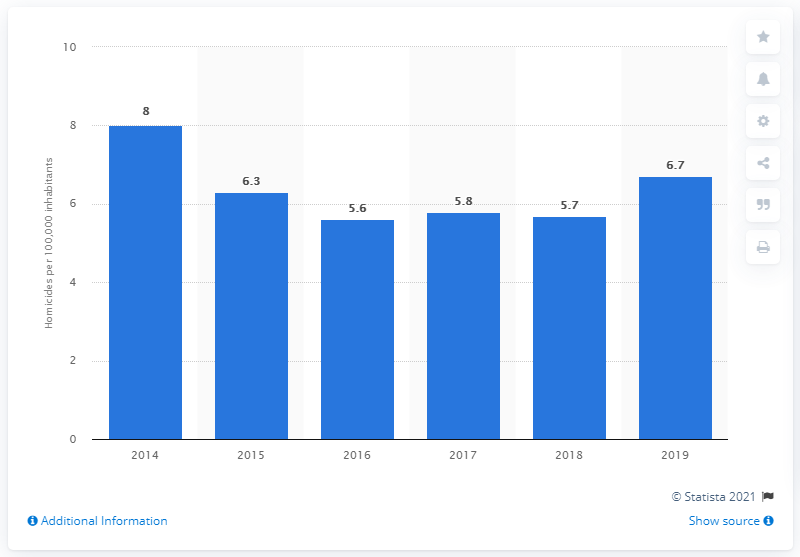Mention a couple of crucial points in this snapshot. In 2019, the homicide rate in Ecuador was 6.7 per 100,000 inhabitants. In 2019, the homicide rate in Ecuador stopped decreasing. 